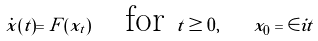<formula> <loc_0><loc_0><loc_500><loc_500>\dot { x } ( t ) = F ( x _ { t } ) \quad \text {for } t \geq 0 , \quad x _ { 0 } & = \in i t</formula> 